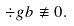Convert formula to latex. <formula><loc_0><loc_0><loc_500><loc_500>\div g b \not \equiv 0 .</formula> 